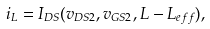Convert formula to latex. <formula><loc_0><loc_0><loc_500><loc_500>i _ { L } = I _ { D S } ( v _ { D S 2 } , v _ { G S 2 } , L - L _ { e f f } ) ,</formula> 